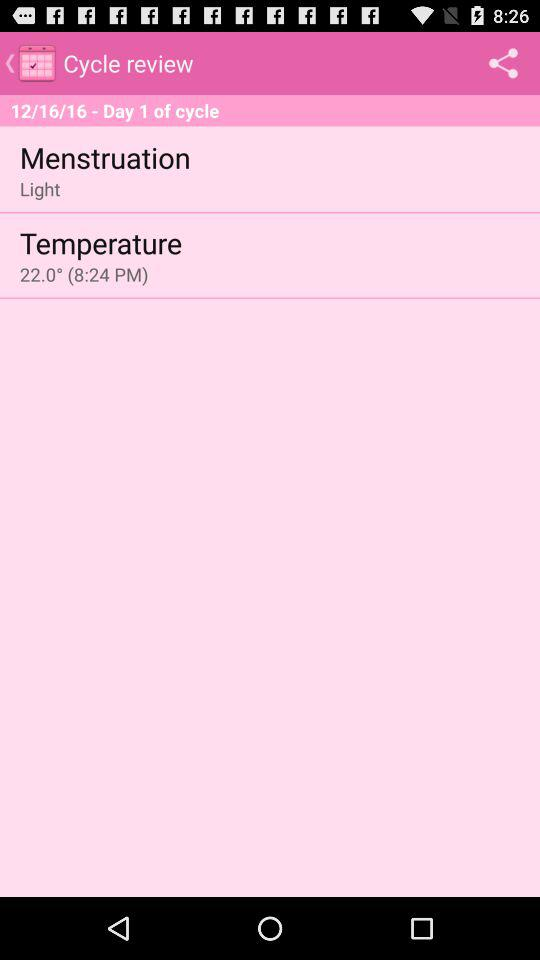What is the temperature?
Answer the question using a single word or phrase. 22.0° 